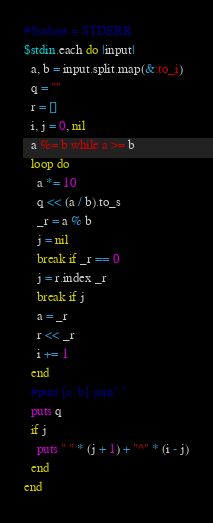Convert code to text. <code><loc_0><loc_0><loc_500><loc_500><_Ruby_>#$stdout = STDERR
$stdin.each do |input|
  a, b = input.split.map(&:to_i)
  q = ""
  r = []
  i, j = 0, nil
  a %= b while a >= b
  loop do
    a *= 10
    q << (a / b).to_s
    _r = a % b
    j = nil
    break if _r == 0
    j = r.index _r
    break if j
    a = _r
    r << _r
    i += 1
  end
  #puts [a, b].join" "
  puts q
  if j
    puts " " * (j + 1) + "^" * (i - j)
  end
end</code> 